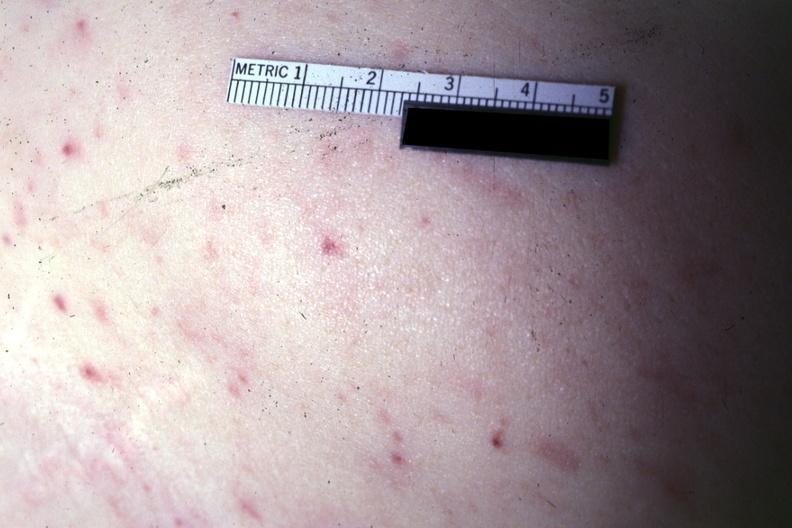where is this?
Answer the question using a single word or phrase. Skin 